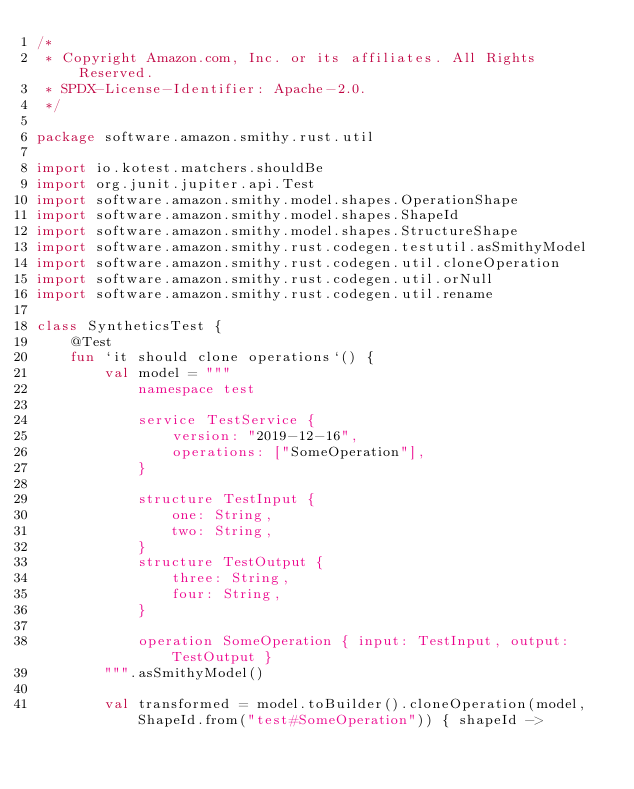Convert code to text. <code><loc_0><loc_0><loc_500><loc_500><_Kotlin_>/*
 * Copyright Amazon.com, Inc. or its affiliates. All Rights Reserved.
 * SPDX-License-Identifier: Apache-2.0.
 */

package software.amazon.smithy.rust.util

import io.kotest.matchers.shouldBe
import org.junit.jupiter.api.Test
import software.amazon.smithy.model.shapes.OperationShape
import software.amazon.smithy.model.shapes.ShapeId
import software.amazon.smithy.model.shapes.StructureShape
import software.amazon.smithy.rust.codegen.testutil.asSmithyModel
import software.amazon.smithy.rust.codegen.util.cloneOperation
import software.amazon.smithy.rust.codegen.util.orNull
import software.amazon.smithy.rust.codegen.util.rename

class SyntheticsTest {
    @Test
    fun `it should clone operations`() {
        val model = """
            namespace test

            service TestService {
                version: "2019-12-16",
                operations: ["SomeOperation"],
            }

            structure TestInput {
                one: String,
                two: String,
            }
            structure TestOutput {
                three: String,
                four: String,
            }

            operation SomeOperation { input: TestInput, output: TestOutput }
        """.asSmithyModel()

        val transformed = model.toBuilder().cloneOperation(model, ShapeId.from("test#SomeOperation")) { shapeId -></code> 